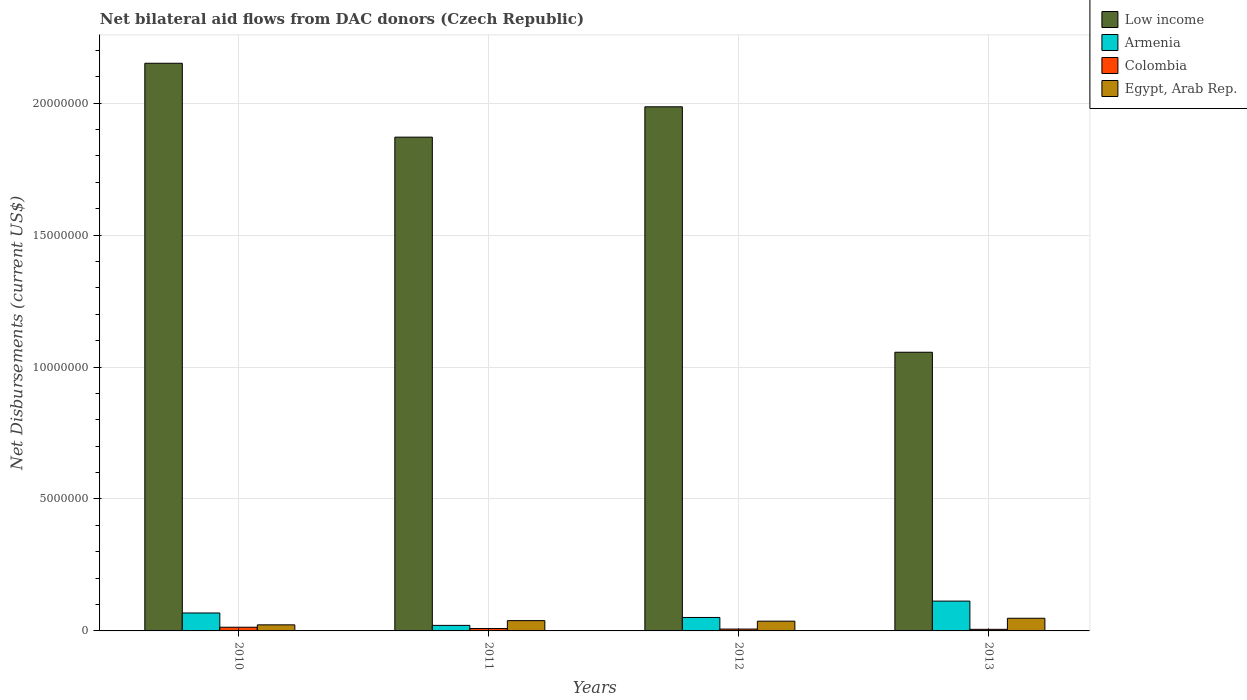What is the label of the 2nd group of bars from the left?
Provide a short and direct response. 2011. What is the net bilateral aid flows in Egypt, Arab Rep. in 2010?
Offer a very short reply. 2.30e+05. Across all years, what is the maximum net bilateral aid flows in Low income?
Your answer should be compact. 2.15e+07. Across all years, what is the minimum net bilateral aid flows in Colombia?
Keep it short and to the point. 6.00e+04. In which year was the net bilateral aid flows in Egypt, Arab Rep. minimum?
Give a very brief answer. 2010. What is the total net bilateral aid flows in Armenia in the graph?
Offer a very short reply. 2.53e+06. What is the difference between the net bilateral aid flows in Colombia in 2011 and that in 2012?
Offer a very short reply. 2.00e+04. What is the difference between the net bilateral aid flows in Low income in 2011 and the net bilateral aid flows in Armenia in 2012?
Your response must be concise. 1.82e+07. What is the average net bilateral aid flows in Low income per year?
Ensure brevity in your answer.  1.77e+07. In the year 2013, what is the difference between the net bilateral aid flows in Armenia and net bilateral aid flows in Colombia?
Make the answer very short. 1.07e+06. In how many years, is the net bilateral aid flows in Low income greater than 10000000 US$?
Your response must be concise. 4. What is the ratio of the net bilateral aid flows in Colombia in 2010 to that in 2011?
Your response must be concise. 1.56. Is the net bilateral aid flows in Egypt, Arab Rep. in 2012 less than that in 2013?
Provide a succinct answer. Yes. What is the difference between the highest and the second highest net bilateral aid flows in Low income?
Provide a succinct answer. 1.65e+06. What is the difference between the highest and the lowest net bilateral aid flows in Low income?
Offer a terse response. 1.10e+07. Is it the case that in every year, the sum of the net bilateral aid flows in Egypt, Arab Rep. and net bilateral aid flows in Colombia is greater than the sum of net bilateral aid flows in Low income and net bilateral aid flows in Armenia?
Provide a short and direct response. Yes. What does the 4th bar from the left in 2011 represents?
Your response must be concise. Egypt, Arab Rep. What does the 3rd bar from the right in 2012 represents?
Your response must be concise. Armenia. How many bars are there?
Provide a short and direct response. 16. What is the difference between two consecutive major ticks on the Y-axis?
Keep it short and to the point. 5.00e+06. Are the values on the major ticks of Y-axis written in scientific E-notation?
Your answer should be compact. No. Does the graph contain any zero values?
Ensure brevity in your answer.  No. Does the graph contain grids?
Offer a very short reply. Yes. What is the title of the graph?
Offer a very short reply. Net bilateral aid flows from DAC donors (Czech Republic). Does "Liberia" appear as one of the legend labels in the graph?
Make the answer very short. No. What is the label or title of the Y-axis?
Provide a succinct answer. Net Disbursements (current US$). What is the Net Disbursements (current US$) in Low income in 2010?
Give a very brief answer. 2.15e+07. What is the Net Disbursements (current US$) of Armenia in 2010?
Give a very brief answer. 6.80e+05. What is the Net Disbursements (current US$) in Colombia in 2010?
Ensure brevity in your answer.  1.40e+05. What is the Net Disbursements (current US$) of Low income in 2011?
Give a very brief answer. 1.87e+07. What is the Net Disbursements (current US$) of Armenia in 2011?
Make the answer very short. 2.10e+05. What is the Net Disbursements (current US$) in Colombia in 2011?
Provide a short and direct response. 9.00e+04. What is the Net Disbursements (current US$) in Egypt, Arab Rep. in 2011?
Offer a very short reply. 3.90e+05. What is the Net Disbursements (current US$) in Low income in 2012?
Offer a very short reply. 1.99e+07. What is the Net Disbursements (current US$) in Armenia in 2012?
Your response must be concise. 5.10e+05. What is the Net Disbursements (current US$) of Colombia in 2012?
Ensure brevity in your answer.  7.00e+04. What is the Net Disbursements (current US$) of Low income in 2013?
Make the answer very short. 1.06e+07. What is the Net Disbursements (current US$) of Armenia in 2013?
Provide a short and direct response. 1.13e+06. What is the Net Disbursements (current US$) in Egypt, Arab Rep. in 2013?
Your answer should be very brief. 4.80e+05. Across all years, what is the maximum Net Disbursements (current US$) in Low income?
Your response must be concise. 2.15e+07. Across all years, what is the maximum Net Disbursements (current US$) in Armenia?
Offer a very short reply. 1.13e+06. Across all years, what is the minimum Net Disbursements (current US$) in Low income?
Your answer should be compact. 1.06e+07. Across all years, what is the minimum Net Disbursements (current US$) of Armenia?
Offer a terse response. 2.10e+05. Across all years, what is the minimum Net Disbursements (current US$) of Egypt, Arab Rep.?
Provide a short and direct response. 2.30e+05. What is the total Net Disbursements (current US$) in Low income in the graph?
Offer a very short reply. 7.06e+07. What is the total Net Disbursements (current US$) in Armenia in the graph?
Your answer should be very brief. 2.53e+06. What is the total Net Disbursements (current US$) of Colombia in the graph?
Your answer should be compact. 3.60e+05. What is the total Net Disbursements (current US$) in Egypt, Arab Rep. in the graph?
Your answer should be compact. 1.47e+06. What is the difference between the Net Disbursements (current US$) of Low income in 2010 and that in 2011?
Keep it short and to the point. 2.80e+06. What is the difference between the Net Disbursements (current US$) in Low income in 2010 and that in 2012?
Provide a succinct answer. 1.65e+06. What is the difference between the Net Disbursements (current US$) of Colombia in 2010 and that in 2012?
Ensure brevity in your answer.  7.00e+04. What is the difference between the Net Disbursements (current US$) in Low income in 2010 and that in 2013?
Offer a terse response. 1.10e+07. What is the difference between the Net Disbursements (current US$) in Armenia in 2010 and that in 2013?
Keep it short and to the point. -4.50e+05. What is the difference between the Net Disbursements (current US$) in Colombia in 2010 and that in 2013?
Give a very brief answer. 8.00e+04. What is the difference between the Net Disbursements (current US$) in Low income in 2011 and that in 2012?
Keep it short and to the point. -1.15e+06. What is the difference between the Net Disbursements (current US$) in Armenia in 2011 and that in 2012?
Your response must be concise. -3.00e+05. What is the difference between the Net Disbursements (current US$) of Egypt, Arab Rep. in 2011 and that in 2012?
Your answer should be compact. 2.00e+04. What is the difference between the Net Disbursements (current US$) in Low income in 2011 and that in 2013?
Your response must be concise. 8.15e+06. What is the difference between the Net Disbursements (current US$) in Armenia in 2011 and that in 2013?
Provide a short and direct response. -9.20e+05. What is the difference between the Net Disbursements (current US$) in Colombia in 2011 and that in 2013?
Keep it short and to the point. 3.00e+04. What is the difference between the Net Disbursements (current US$) of Low income in 2012 and that in 2013?
Keep it short and to the point. 9.30e+06. What is the difference between the Net Disbursements (current US$) of Armenia in 2012 and that in 2013?
Offer a very short reply. -6.20e+05. What is the difference between the Net Disbursements (current US$) in Egypt, Arab Rep. in 2012 and that in 2013?
Your response must be concise. -1.10e+05. What is the difference between the Net Disbursements (current US$) in Low income in 2010 and the Net Disbursements (current US$) in Armenia in 2011?
Keep it short and to the point. 2.13e+07. What is the difference between the Net Disbursements (current US$) of Low income in 2010 and the Net Disbursements (current US$) of Colombia in 2011?
Provide a succinct answer. 2.14e+07. What is the difference between the Net Disbursements (current US$) in Low income in 2010 and the Net Disbursements (current US$) in Egypt, Arab Rep. in 2011?
Offer a terse response. 2.11e+07. What is the difference between the Net Disbursements (current US$) of Armenia in 2010 and the Net Disbursements (current US$) of Colombia in 2011?
Your answer should be compact. 5.90e+05. What is the difference between the Net Disbursements (current US$) in Low income in 2010 and the Net Disbursements (current US$) in Armenia in 2012?
Your answer should be compact. 2.10e+07. What is the difference between the Net Disbursements (current US$) of Low income in 2010 and the Net Disbursements (current US$) of Colombia in 2012?
Give a very brief answer. 2.14e+07. What is the difference between the Net Disbursements (current US$) in Low income in 2010 and the Net Disbursements (current US$) in Egypt, Arab Rep. in 2012?
Your response must be concise. 2.11e+07. What is the difference between the Net Disbursements (current US$) of Armenia in 2010 and the Net Disbursements (current US$) of Colombia in 2012?
Your answer should be very brief. 6.10e+05. What is the difference between the Net Disbursements (current US$) of Colombia in 2010 and the Net Disbursements (current US$) of Egypt, Arab Rep. in 2012?
Offer a very short reply. -2.30e+05. What is the difference between the Net Disbursements (current US$) of Low income in 2010 and the Net Disbursements (current US$) of Armenia in 2013?
Your answer should be compact. 2.04e+07. What is the difference between the Net Disbursements (current US$) in Low income in 2010 and the Net Disbursements (current US$) in Colombia in 2013?
Your answer should be very brief. 2.14e+07. What is the difference between the Net Disbursements (current US$) in Low income in 2010 and the Net Disbursements (current US$) in Egypt, Arab Rep. in 2013?
Keep it short and to the point. 2.10e+07. What is the difference between the Net Disbursements (current US$) in Armenia in 2010 and the Net Disbursements (current US$) in Colombia in 2013?
Provide a succinct answer. 6.20e+05. What is the difference between the Net Disbursements (current US$) in Colombia in 2010 and the Net Disbursements (current US$) in Egypt, Arab Rep. in 2013?
Give a very brief answer. -3.40e+05. What is the difference between the Net Disbursements (current US$) in Low income in 2011 and the Net Disbursements (current US$) in Armenia in 2012?
Ensure brevity in your answer.  1.82e+07. What is the difference between the Net Disbursements (current US$) in Low income in 2011 and the Net Disbursements (current US$) in Colombia in 2012?
Keep it short and to the point. 1.86e+07. What is the difference between the Net Disbursements (current US$) in Low income in 2011 and the Net Disbursements (current US$) in Egypt, Arab Rep. in 2012?
Give a very brief answer. 1.83e+07. What is the difference between the Net Disbursements (current US$) in Colombia in 2011 and the Net Disbursements (current US$) in Egypt, Arab Rep. in 2012?
Your response must be concise. -2.80e+05. What is the difference between the Net Disbursements (current US$) of Low income in 2011 and the Net Disbursements (current US$) of Armenia in 2013?
Your response must be concise. 1.76e+07. What is the difference between the Net Disbursements (current US$) in Low income in 2011 and the Net Disbursements (current US$) in Colombia in 2013?
Your response must be concise. 1.86e+07. What is the difference between the Net Disbursements (current US$) in Low income in 2011 and the Net Disbursements (current US$) in Egypt, Arab Rep. in 2013?
Give a very brief answer. 1.82e+07. What is the difference between the Net Disbursements (current US$) in Armenia in 2011 and the Net Disbursements (current US$) in Colombia in 2013?
Keep it short and to the point. 1.50e+05. What is the difference between the Net Disbursements (current US$) in Armenia in 2011 and the Net Disbursements (current US$) in Egypt, Arab Rep. in 2013?
Your answer should be very brief. -2.70e+05. What is the difference between the Net Disbursements (current US$) of Colombia in 2011 and the Net Disbursements (current US$) of Egypt, Arab Rep. in 2013?
Offer a terse response. -3.90e+05. What is the difference between the Net Disbursements (current US$) of Low income in 2012 and the Net Disbursements (current US$) of Armenia in 2013?
Offer a terse response. 1.87e+07. What is the difference between the Net Disbursements (current US$) of Low income in 2012 and the Net Disbursements (current US$) of Colombia in 2013?
Provide a short and direct response. 1.98e+07. What is the difference between the Net Disbursements (current US$) of Low income in 2012 and the Net Disbursements (current US$) of Egypt, Arab Rep. in 2013?
Your answer should be compact. 1.94e+07. What is the difference between the Net Disbursements (current US$) of Armenia in 2012 and the Net Disbursements (current US$) of Colombia in 2013?
Your answer should be very brief. 4.50e+05. What is the difference between the Net Disbursements (current US$) in Armenia in 2012 and the Net Disbursements (current US$) in Egypt, Arab Rep. in 2013?
Provide a succinct answer. 3.00e+04. What is the difference between the Net Disbursements (current US$) in Colombia in 2012 and the Net Disbursements (current US$) in Egypt, Arab Rep. in 2013?
Provide a short and direct response. -4.10e+05. What is the average Net Disbursements (current US$) of Low income per year?
Your response must be concise. 1.77e+07. What is the average Net Disbursements (current US$) of Armenia per year?
Your answer should be compact. 6.32e+05. What is the average Net Disbursements (current US$) in Colombia per year?
Provide a succinct answer. 9.00e+04. What is the average Net Disbursements (current US$) in Egypt, Arab Rep. per year?
Your answer should be compact. 3.68e+05. In the year 2010, what is the difference between the Net Disbursements (current US$) in Low income and Net Disbursements (current US$) in Armenia?
Offer a terse response. 2.08e+07. In the year 2010, what is the difference between the Net Disbursements (current US$) in Low income and Net Disbursements (current US$) in Colombia?
Make the answer very short. 2.14e+07. In the year 2010, what is the difference between the Net Disbursements (current US$) in Low income and Net Disbursements (current US$) in Egypt, Arab Rep.?
Give a very brief answer. 2.13e+07. In the year 2010, what is the difference between the Net Disbursements (current US$) in Armenia and Net Disbursements (current US$) in Colombia?
Keep it short and to the point. 5.40e+05. In the year 2010, what is the difference between the Net Disbursements (current US$) of Armenia and Net Disbursements (current US$) of Egypt, Arab Rep.?
Offer a very short reply. 4.50e+05. In the year 2010, what is the difference between the Net Disbursements (current US$) of Colombia and Net Disbursements (current US$) of Egypt, Arab Rep.?
Make the answer very short. -9.00e+04. In the year 2011, what is the difference between the Net Disbursements (current US$) of Low income and Net Disbursements (current US$) of Armenia?
Offer a very short reply. 1.85e+07. In the year 2011, what is the difference between the Net Disbursements (current US$) of Low income and Net Disbursements (current US$) of Colombia?
Give a very brief answer. 1.86e+07. In the year 2011, what is the difference between the Net Disbursements (current US$) of Low income and Net Disbursements (current US$) of Egypt, Arab Rep.?
Make the answer very short. 1.83e+07. In the year 2011, what is the difference between the Net Disbursements (current US$) in Armenia and Net Disbursements (current US$) in Egypt, Arab Rep.?
Offer a terse response. -1.80e+05. In the year 2012, what is the difference between the Net Disbursements (current US$) of Low income and Net Disbursements (current US$) of Armenia?
Give a very brief answer. 1.94e+07. In the year 2012, what is the difference between the Net Disbursements (current US$) in Low income and Net Disbursements (current US$) in Colombia?
Make the answer very short. 1.98e+07. In the year 2012, what is the difference between the Net Disbursements (current US$) in Low income and Net Disbursements (current US$) in Egypt, Arab Rep.?
Give a very brief answer. 1.95e+07. In the year 2012, what is the difference between the Net Disbursements (current US$) of Armenia and Net Disbursements (current US$) of Egypt, Arab Rep.?
Provide a succinct answer. 1.40e+05. In the year 2012, what is the difference between the Net Disbursements (current US$) in Colombia and Net Disbursements (current US$) in Egypt, Arab Rep.?
Offer a very short reply. -3.00e+05. In the year 2013, what is the difference between the Net Disbursements (current US$) in Low income and Net Disbursements (current US$) in Armenia?
Your response must be concise. 9.43e+06. In the year 2013, what is the difference between the Net Disbursements (current US$) in Low income and Net Disbursements (current US$) in Colombia?
Provide a succinct answer. 1.05e+07. In the year 2013, what is the difference between the Net Disbursements (current US$) of Low income and Net Disbursements (current US$) of Egypt, Arab Rep.?
Offer a terse response. 1.01e+07. In the year 2013, what is the difference between the Net Disbursements (current US$) of Armenia and Net Disbursements (current US$) of Colombia?
Your response must be concise. 1.07e+06. In the year 2013, what is the difference between the Net Disbursements (current US$) of Armenia and Net Disbursements (current US$) of Egypt, Arab Rep.?
Your answer should be very brief. 6.50e+05. In the year 2013, what is the difference between the Net Disbursements (current US$) in Colombia and Net Disbursements (current US$) in Egypt, Arab Rep.?
Make the answer very short. -4.20e+05. What is the ratio of the Net Disbursements (current US$) of Low income in 2010 to that in 2011?
Make the answer very short. 1.15. What is the ratio of the Net Disbursements (current US$) of Armenia in 2010 to that in 2011?
Provide a short and direct response. 3.24. What is the ratio of the Net Disbursements (current US$) in Colombia in 2010 to that in 2011?
Your response must be concise. 1.56. What is the ratio of the Net Disbursements (current US$) of Egypt, Arab Rep. in 2010 to that in 2011?
Ensure brevity in your answer.  0.59. What is the ratio of the Net Disbursements (current US$) of Low income in 2010 to that in 2012?
Make the answer very short. 1.08. What is the ratio of the Net Disbursements (current US$) of Colombia in 2010 to that in 2012?
Provide a short and direct response. 2. What is the ratio of the Net Disbursements (current US$) in Egypt, Arab Rep. in 2010 to that in 2012?
Your answer should be very brief. 0.62. What is the ratio of the Net Disbursements (current US$) of Low income in 2010 to that in 2013?
Provide a succinct answer. 2.04. What is the ratio of the Net Disbursements (current US$) of Armenia in 2010 to that in 2013?
Offer a terse response. 0.6. What is the ratio of the Net Disbursements (current US$) of Colombia in 2010 to that in 2013?
Keep it short and to the point. 2.33. What is the ratio of the Net Disbursements (current US$) in Egypt, Arab Rep. in 2010 to that in 2013?
Make the answer very short. 0.48. What is the ratio of the Net Disbursements (current US$) in Low income in 2011 to that in 2012?
Your answer should be compact. 0.94. What is the ratio of the Net Disbursements (current US$) in Armenia in 2011 to that in 2012?
Provide a short and direct response. 0.41. What is the ratio of the Net Disbursements (current US$) in Egypt, Arab Rep. in 2011 to that in 2012?
Keep it short and to the point. 1.05. What is the ratio of the Net Disbursements (current US$) of Low income in 2011 to that in 2013?
Offer a terse response. 1.77. What is the ratio of the Net Disbursements (current US$) of Armenia in 2011 to that in 2013?
Your response must be concise. 0.19. What is the ratio of the Net Disbursements (current US$) of Egypt, Arab Rep. in 2011 to that in 2013?
Your answer should be compact. 0.81. What is the ratio of the Net Disbursements (current US$) of Low income in 2012 to that in 2013?
Keep it short and to the point. 1.88. What is the ratio of the Net Disbursements (current US$) in Armenia in 2012 to that in 2013?
Your answer should be compact. 0.45. What is the ratio of the Net Disbursements (current US$) in Colombia in 2012 to that in 2013?
Your response must be concise. 1.17. What is the ratio of the Net Disbursements (current US$) in Egypt, Arab Rep. in 2012 to that in 2013?
Give a very brief answer. 0.77. What is the difference between the highest and the second highest Net Disbursements (current US$) in Low income?
Your answer should be compact. 1.65e+06. What is the difference between the highest and the lowest Net Disbursements (current US$) of Low income?
Offer a very short reply. 1.10e+07. What is the difference between the highest and the lowest Net Disbursements (current US$) of Armenia?
Give a very brief answer. 9.20e+05. 